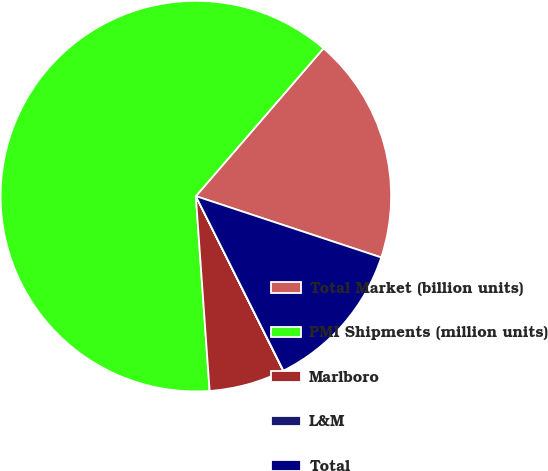Convert chart. <chart><loc_0><loc_0><loc_500><loc_500><pie_chart><fcel>Total Market (billion units)<fcel>PMI Shipments (million units)<fcel>Marlboro<fcel>L&M<fcel>Total<nl><fcel>18.75%<fcel>62.46%<fcel>6.26%<fcel>0.02%<fcel>12.51%<nl></chart> 